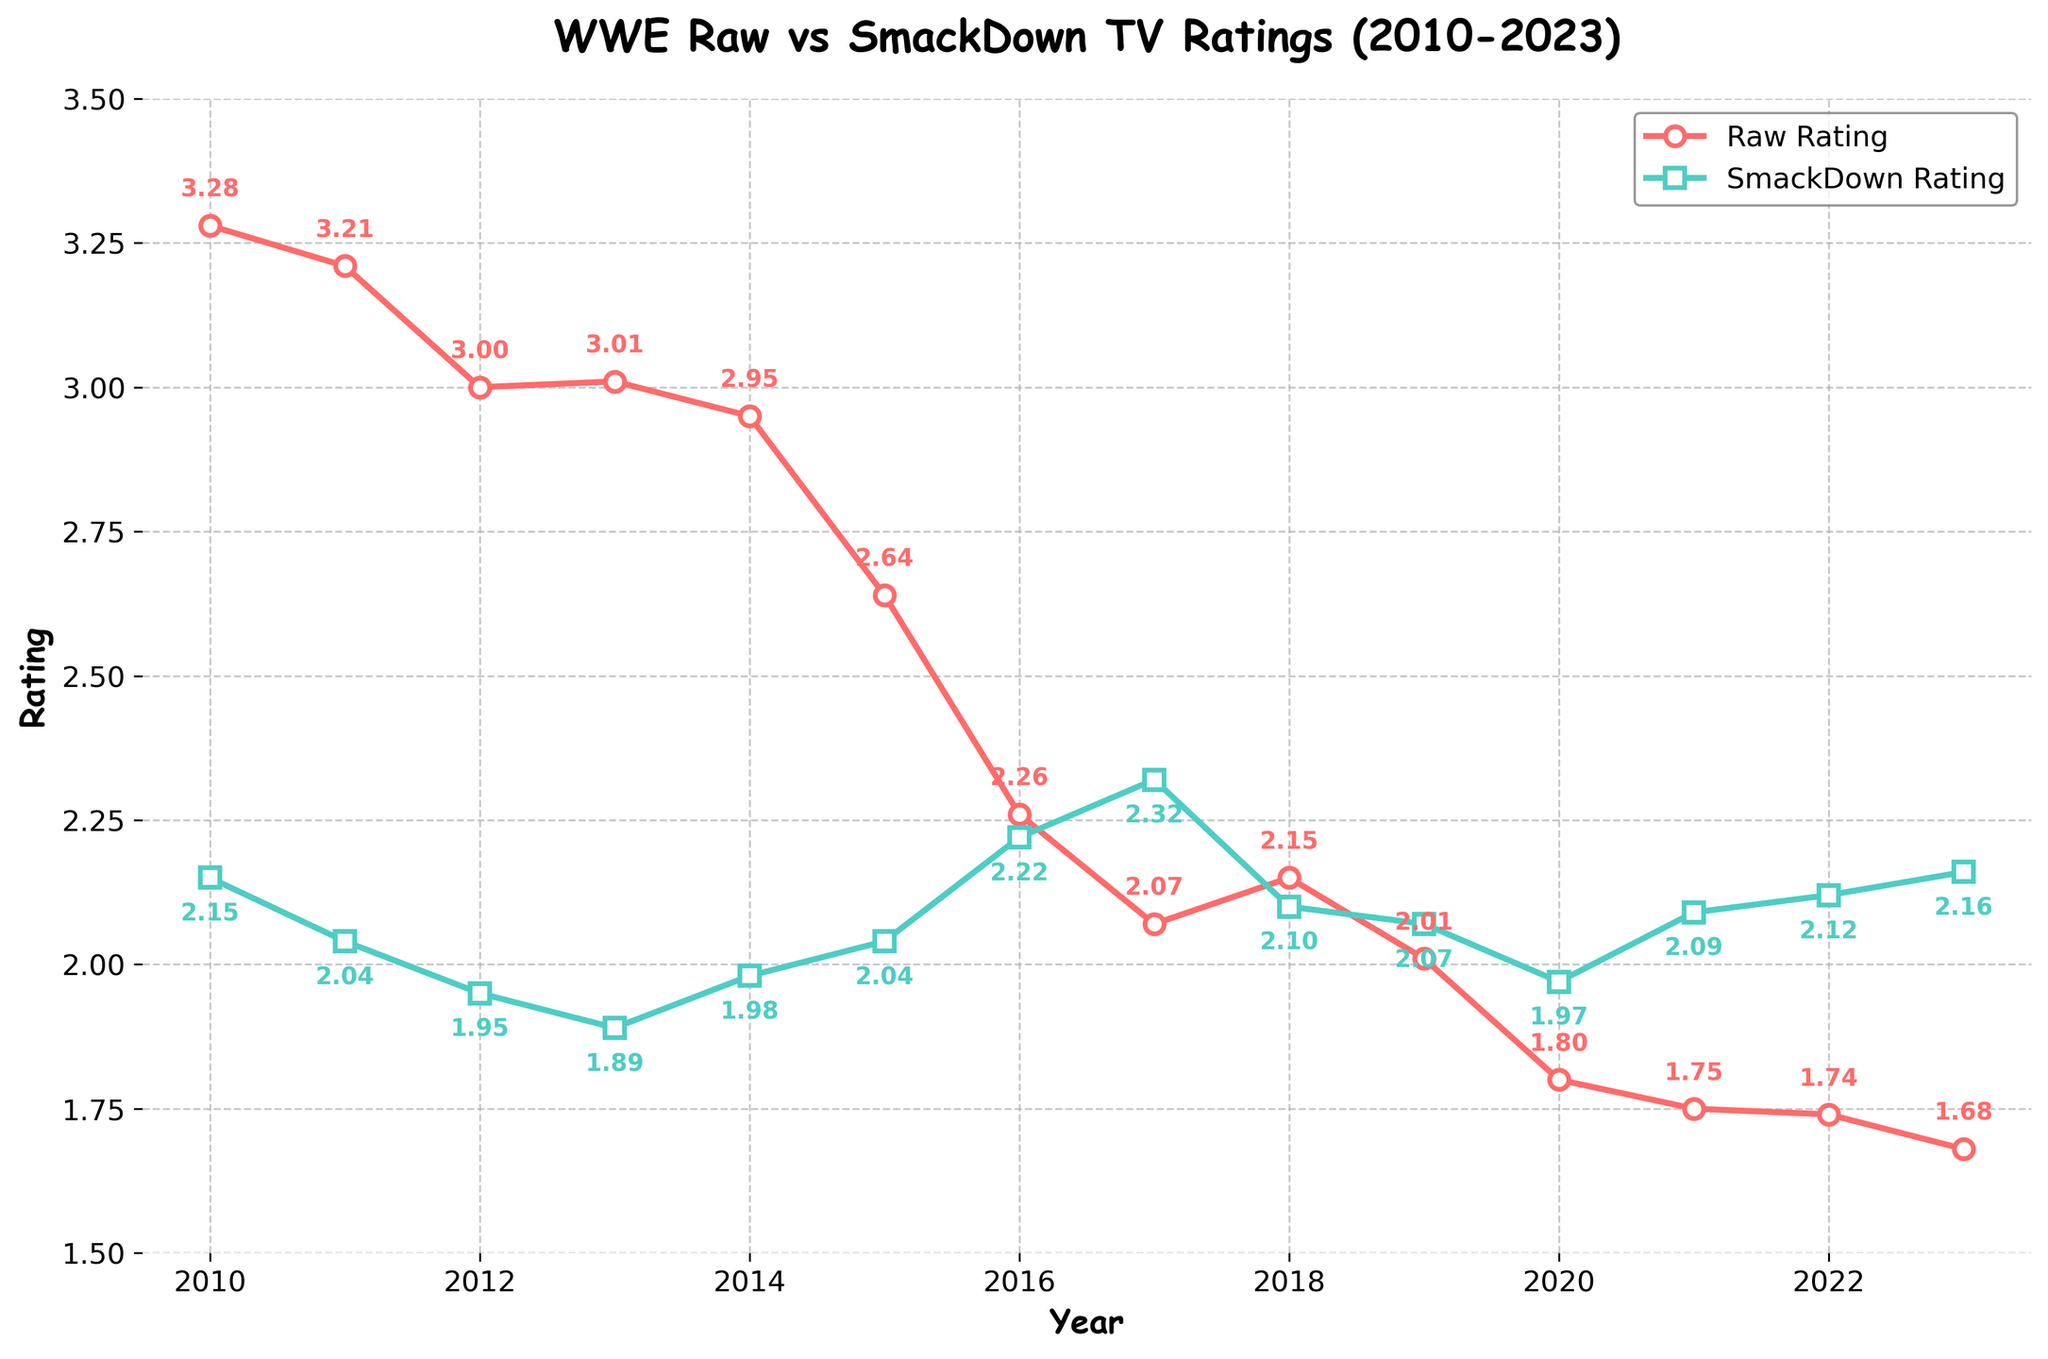What was the rating difference between Raw and SmackDown in 2010? The rating for Raw in 2010 was 3.28, and for SmackDown, it was 2.15. The difference is calculated as 3.28 - 2.15 = 1.13.
Answer: 1.13 In which year did SmackDown surpass Raw in ratings? By looking at the graph, we see that Raw's rating drops below SmackDown's rating starting in 2017.
Answer: 2017 What was the average rating for Raw from 2010 to 2023? The ratings for Raw over the years are 3.28, 3.21, 3.00, 3.01, 2.95, 2.64, 2.26, 2.07, 2.15, 2.01, 1.80, 1.75, 1.74, and 1.68. Summing these gives: 3.28 + 3.21 + 3.00 + 3.01 + 2.95 + 2.64 + 2.26 + 2.07 + 2.15 + 2.01 + 1.80 + 1.75 + 1.74 + 1.68 = 35.55. Dividing by 14 gives an average of 35.55 / 14 ≈ 2.54.
Answer: 2.54 Which year saw the closest ratings between Raw and SmackDown? To determine the closest ratings, we can observe the smallest difference between Raw and SmackDown ratings. In 2016, the difference was particularly small with Raw at 2.26 and SmackDown at 2.22, resulting in a difference of 0.04, which is the smallest observed.
Answer: 2016 By how much did Raw's rating decrease from 2010 to 2023? The rating for Raw in 2010 was 3.28, and in 2023 it was 1.68. The decrease is calculated as 3.28 - 1.68 = 1.60.
Answer: 1.60 What is the trend of ratings for Raw from 2010 to 2023? Raw's rating generally shows a decreasing trend from 2010 (3.28) to 2023 (1.68). This can be observed from the line graph which shows a consistent downward trajectory.
Answer: Decreasing When did SmackDown's rating first exceed the 2.00 mark after 2010? From the data, SmackDown's rating first exceeded the 2.00 mark in 2015, reaching 2.04.
Answer: 2015 What is the ratio of Raw's rating to SmackDown's rating in 2023? The rating for Raw in 2023 is 1.68 and for SmackDown, it is 2.16. The ratio is calculated as 1.68 / 2.16 = 0.78.
Answer: 0.78 Which show had a higher rating in 2021 and what was the difference? In 2021, SmackDown had a higher rating of 2.09 compared to Raw's 1.75. The difference is calculated as 2.09 - 1.75 = 0.34.
Answer: SmackDown, 0.34 What is the relative trend comparison between Raw and SmackDown from 2010 to 2023? While Raw has a clear decreasing trend from 2010 to 2023, SmackDown's trend is more stable and even slightly increasing, especially from 2017 onwards where it surpasses Raw. Visually, Raw consistently declines while SmackDown improves or remains more constant.
Answer: Raw decreasing, SmackDown stable/increasing 